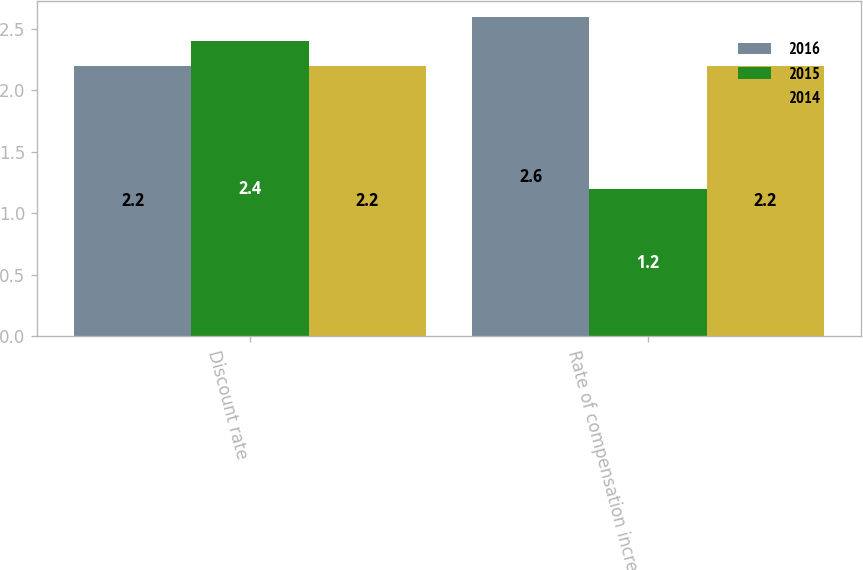Convert chart. <chart><loc_0><loc_0><loc_500><loc_500><stacked_bar_chart><ecel><fcel>Discount rate<fcel>Rate of compensation increase<nl><fcel>2016<fcel>2.2<fcel>2.6<nl><fcel>2015<fcel>2.4<fcel>1.2<nl><fcel>2014<fcel>2.2<fcel>2.2<nl></chart> 